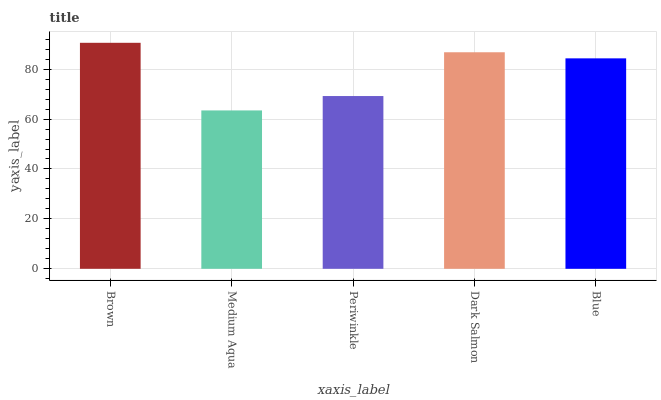Is Medium Aqua the minimum?
Answer yes or no. Yes. Is Brown the maximum?
Answer yes or no. Yes. Is Periwinkle the minimum?
Answer yes or no. No. Is Periwinkle the maximum?
Answer yes or no. No. Is Periwinkle greater than Medium Aqua?
Answer yes or no. Yes. Is Medium Aqua less than Periwinkle?
Answer yes or no. Yes. Is Medium Aqua greater than Periwinkle?
Answer yes or no. No. Is Periwinkle less than Medium Aqua?
Answer yes or no. No. Is Blue the high median?
Answer yes or no. Yes. Is Blue the low median?
Answer yes or no. Yes. Is Periwinkle the high median?
Answer yes or no. No. Is Medium Aqua the low median?
Answer yes or no. No. 